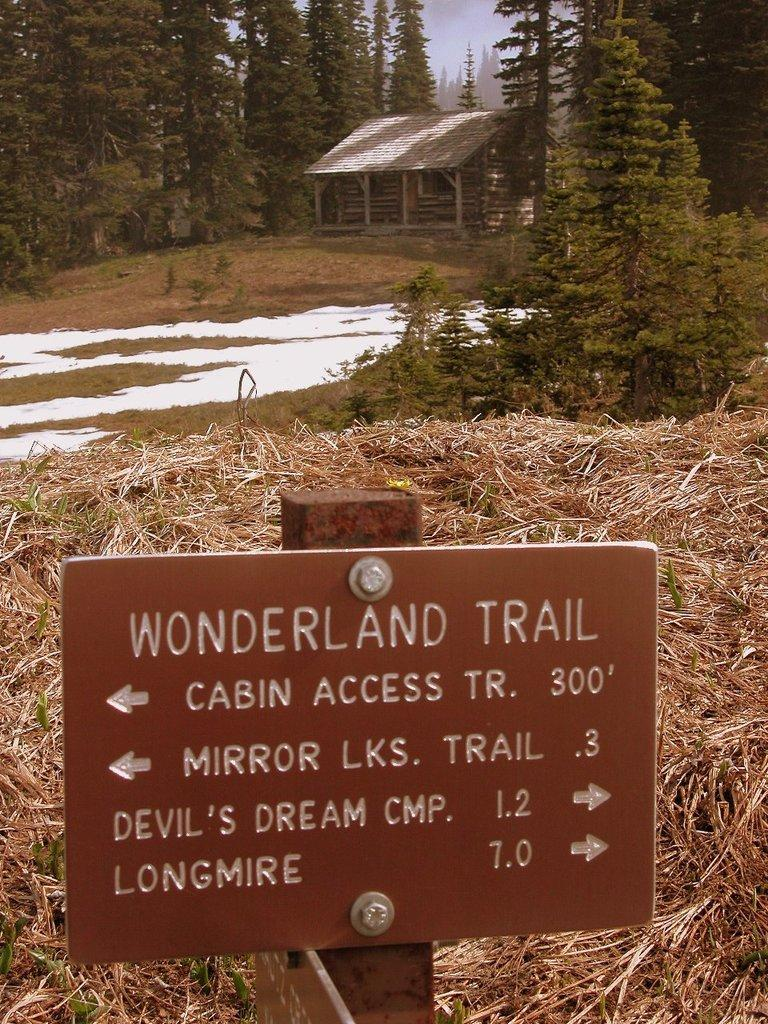What is the main object in the image? There is a sign board in the image. What type of natural environment is visible in the image? There is grass and trees in the image. What type of structure can be seen in the image? There is a shed in the image. What color are the eyes of the orange in the image? There is no orange present in the image, and therefore no eyes to describe. 